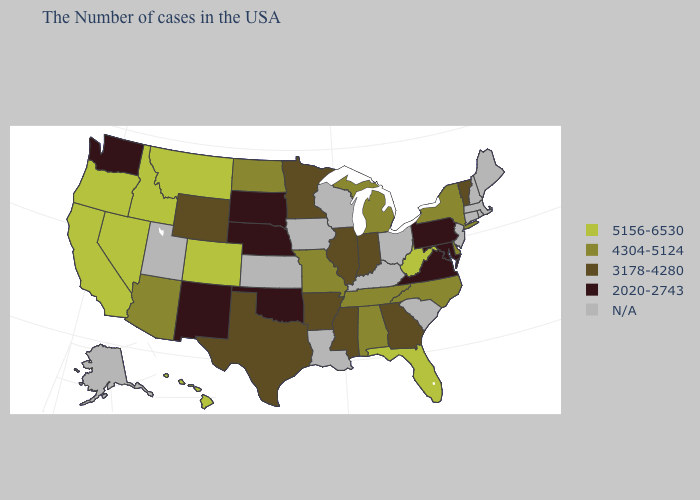What is the value of Iowa?
Short answer required. N/A. Name the states that have a value in the range 5156-6530?
Answer briefly. West Virginia, Florida, Colorado, Montana, Idaho, Nevada, California, Oregon, Hawaii. Name the states that have a value in the range 2020-2743?
Keep it brief. Maryland, Pennsylvania, Virginia, Nebraska, Oklahoma, South Dakota, New Mexico, Washington. Does North Carolina have the highest value in the USA?
Answer briefly. No. Name the states that have a value in the range 5156-6530?
Quick response, please. West Virginia, Florida, Colorado, Montana, Idaho, Nevada, California, Oregon, Hawaii. What is the lowest value in the MidWest?
Keep it brief. 2020-2743. Name the states that have a value in the range 3178-4280?
Write a very short answer. Vermont, Georgia, Indiana, Illinois, Mississippi, Arkansas, Minnesota, Texas, Wyoming. Does Nevada have the highest value in the USA?
Concise answer only. Yes. What is the lowest value in states that border Alabama?
Answer briefly. 3178-4280. Which states have the lowest value in the MidWest?
Keep it brief. Nebraska, South Dakota. What is the value of Alabama?
Concise answer only. 4304-5124. What is the lowest value in the USA?
Short answer required. 2020-2743. What is the value of New York?
Write a very short answer. 4304-5124. Does the first symbol in the legend represent the smallest category?
Quick response, please. No. 